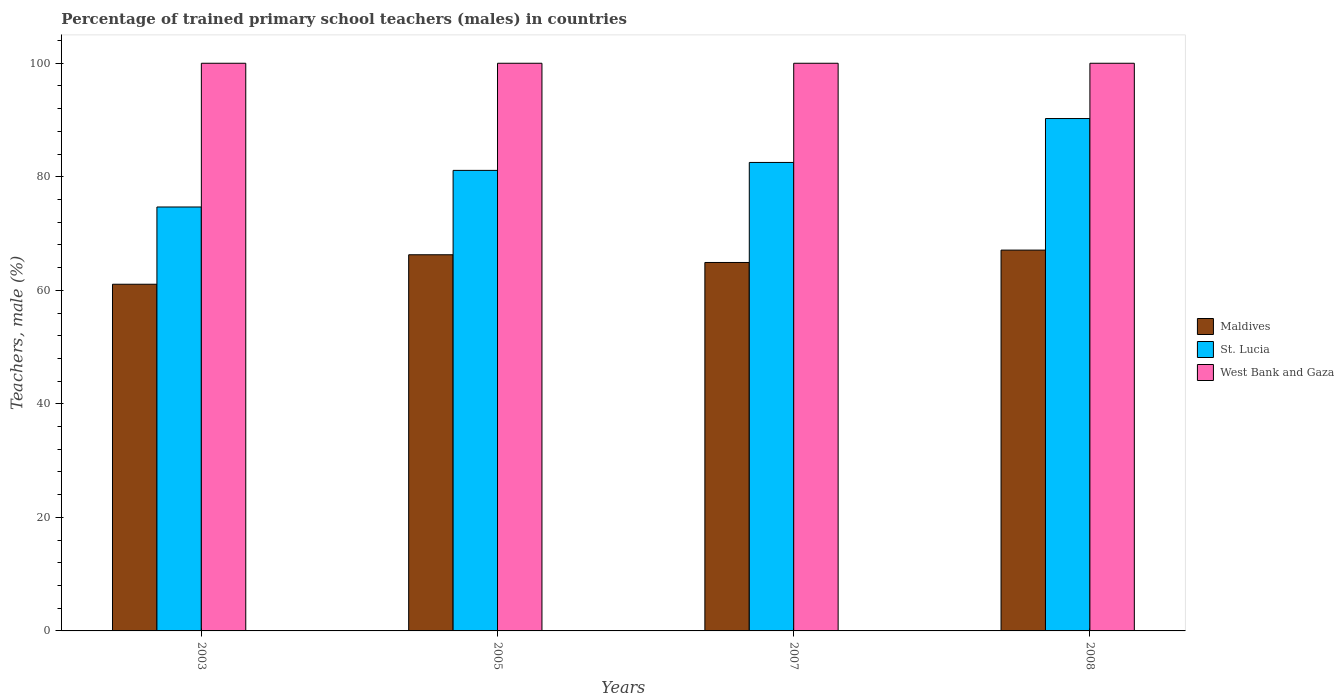How many different coloured bars are there?
Keep it short and to the point. 3. How many groups of bars are there?
Provide a short and direct response. 4. Are the number of bars per tick equal to the number of legend labels?
Give a very brief answer. Yes. Are the number of bars on each tick of the X-axis equal?
Provide a succinct answer. Yes. How many bars are there on the 1st tick from the right?
Offer a terse response. 3. In how many cases, is the number of bars for a given year not equal to the number of legend labels?
Provide a short and direct response. 0. What is the percentage of trained primary school teachers (males) in St. Lucia in 2008?
Offer a terse response. 90.26. Across all years, what is the maximum percentage of trained primary school teachers (males) in West Bank and Gaza?
Your response must be concise. 100. Across all years, what is the minimum percentage of trained primary school teachers (males) in Maldives?
Ensure brevity in your answer.  61.07. In which year was the percentage of trained primary school teachers (males) in St. Lucia maximum?
Offer a terse response. 2008. What is the total percentage of trained primary school teachers (males) in St. Lucia in the graph?
Provide a succinct answer. 328.6. What is the difference between the percentage of trained primary school teachers (males) in St. Lucia in 2005 and that in 2007?
Offer a terse response. -1.4. What is the difference between the percentage of trained primary school teachers (males) in West Bank and Gaza in 2007 and the percentage of trained primary school teachers (males) in Maldives in 2003?
Your answer should be very brief. 38.93. What is the average percentage of trained primary school teachers (males) in Maldives per year?
Provide a succinct answer. 64.83. In the year 2007, what is the difference between the percentage of trained primary school teachers (males) in Maldives and percentage of trained primary school teachers (males) in West Bank and Gaza?
Offer a very short reply. -35.09. In how many years, is the percentage of trained primary school teachers (males) in St. Lucia greater than 12 %?
Offer a very short reply. 4. What is the ratio of the percentage of trained primary school teachers (males) in St. Lucia in 2003 to that in 2007?
Ensure brevity in your answer.  0.9. Is the difference between the percentage of trained primary school teachers (males) in Maldives in 2005 and 2007 greater than the difference between the percentage of trained primary school teachers (males) in West Bank and Gaza in 2005 and 2007?
Ensure brevity in your answer.  Yes. What is the difference between the highest and the second highest percentage of trained primary school teachers (males) in St. Lucia?
Your response must be concise. 7.73. What is the difference between the highest and the lowest percentage of trained primary school teachers (males) in St. Lucia?
Ensure brevity in your answer.  15.58. Is the sum of the percentage of trained primary school teachers (males) in Maldives in 2005 and 2008 greater than the maximum percentage of trained primary school teachers (males) in West Bank and Gaza across all years?
Ensure brevity in your answer.  Yes. What does the 2nd bar from the left in 2007 represents?
Your response must be concise. St. Lucia. What does the 3rd bar from the right in 2007 represents?
Your answer should be very brief. Maldives. Is it the case that in every year, the sum of the percentage of trained primary school teachers (males) in West Bank and Gaza and percentage of trained primary school teachers (males) in St. Lucia is greater than the percentage of trained primary school teachers (males) in Maldives?
Your answer should be compact. Yes. How many bars are there?
Provide a short and direct response. 12. Are all the bars in the graph horizontal?
Offer a very short reply. No. What is the difference between two consecutive major ticks on the Y-axis?
Offer a very short reply. 20. Are the values on the major ticks of Y-axis written in scientific E-notation?
Your answer should be compact. No. How many legend labels are there?
Make the answer very short. 3. What is the title of the graph?
Provide a succinct answer. Percentage of trained primary school teachers (males) in countries. What is the label or title of the X-axis?
Your answer should be very brief. Years. What is the label or title of the Y-axis?
Your answer should be compact. Teachers, male (%). What is the Teachers, male (%) of Maldives in 2003?
Your answer should be very brief. 61.07. What is the Teachers, male (%) in St. Lucia in 2003?
Give a very brief answer. 74.68. What is the Teachers, male (%) in Maldives in 2005?
Your response must be concise. 66.27. What is the Teachers, male (%) of St. Lucia in 2005?
Your answer should be very brief. 81.13. What is the Teachers, male (%) of Maldives in 2007?
Offer a terse response. 64.91. What is the Teachers, male (%) in St. Lucia in 2007?
Your answer should be compact. 82.53. What is the Teachers, male (%) of Maldives in 2008?
Provide a short and direct response. 67.08. What is the Teachers, male (%) of St. Lucia in 2008?
Give a very brief answer. 90.26. Across all years, what is the maximum Teachers, male (%) in Maldives?
Give a very brief answer. 67.08. Across all years, what is the maximum Teachers, male (%) in St. Lucia?
Provide a succinct answer. 90.26. Across all years, what is the maximum Teachers, male (%) of West Bank and Gaza?
Your response must be concise. 100. Across all years, what is the minimum Teachers, male (%) in Maldives?
Your response must be concise. 61.07. Across all years, what is the minimum Teachers, male (%) in St. Lucia?
Ensure brevity in your answer.  74.68. What is the total Teachers, male (%) of Maldives in the graph?
Your answer should be compact. 259.33. What is the total Teachers, male (%) in St. Lucia in the graph?
Make the answer very short. 328.6. What is the difference between the Teachers, male (%) of Maldives in 2003 and that in 2005?
Offer a very short reply. -5.19. What is the difference between the Teachers, male (%) of St. Lucia in 2003 and that in 2005?
Offer a terse response. -6.45. What is the difference between the Teachers, male (%) of West Bank and Gaza in 2003 and that in 2005?
Provide a succinct answer. 0. What is the difference between the Teachers, male (%) in Maldives in 2003 and that in 2007?
Provide a short and direct response. -3.84. What is the difference between the Teachers, male (%) in St. Lucia in 2003 and that in 2007?
Offer a very short reply. -7.85. What is the difference between the Teachers, male (%) of Maldives in 2003 and that in 2008?
Your answer should be compact. -6.01. What is the difference between the Teachers, male (%) in St. Lucia in 2003 and that in 2008?
Give a very brief answer. -15.58. What is the difference between the Teachers, male (%) of Maldives in 2005 and that in 2007?
Provide a succinct answer. 1.36. What is the difference between the Teachers, male (%) in St. Lucia in 2005 and that in 2007?
Give a very brief answer. -1.4. What is the difference between the Teachers, male (%) of Maldives in 2005 and that in 2008?
Keep it short and to the point. -0.82. What is the difference between the Teachers, male (%) in St. Lucia in 2005 and that in 2008?
Give a very brief answer. -9.13. What is the difference between the Teachers, male (%) in Maldives in 2007 and that in 2008?
Ensure brevity in your answer.  -2.18. What is the difference between the Teachers, male (%) of St. Lucia in 2007 and that in 2008?
Your answer should be compact. -7.73. What is the difference between the Teachers, male (%) of West Bank and Gaza in 2007 and that in 2008?
Ensure brevity in your answer.  0. What is the difference between the Teachers, male (%) of Maldives in 2003 and the Teachers, male (%) of St. Lucia in 2005?
Ensure brevity in your answer.  -20.06. What is the difference between the Teachers, male (%) of Maldives in 2003 and the Teachers, male (%) of West Bank and Gaza in 2005?
Your answer should be very brief. -38.93. What is the difference between the Teachers, male (%) of St. Lucia in 2003 and the Teachers, male (%) of West Bank and Gaza in 2005?
Provide a succinct answer. -25.32. What is the difference between the Teachers, male (%) in Maldives in 2003 and the Teachers, male (%) in St. Lucia in 2007?
Your answer should be compact. -21.46. What is the difference between the Teachers, male (%) of Maldives in 2003 and the Teachers, male (%) of West Bank and Gaza in 2007?
Offer a very short reply. -38.93. What is the difference between the Teachers, male (%) in St. Lucia in 2003 and the Teachers, male (%) in West Bank and Gaza in 2007?
Provide a short and direct response. -25.32. What is the difference between the Teachers, male (%) in Maldives in 2003 and the Teachers, male (%) in St. Lucia in 2008?
Your answer should be very brief. -29.19. What is the difference between the Teachers, male (%) in Maldives in 2003 and the Teachers, male (%) in West Bank and Gaza in 2008?
Provide a succinct answer. -38.93. What is the difference between the Teachers, male (%) of St. Lucia in 2003 and the Teachers, male (%) of West Bank and Gaza in 2008?
Your response must be concise. -25.32. What is the difference between the Teachers, male (%) in Maldives in 2005 and the Teachers, male (%) in St. Lucia in 2007?
Your answer should be compact. -16.26. What is the difference between the Teachers, male (%) in Maldives in 2005 and the Teachers, male (%) in West Bank and Gaza in 2007?
Your answer should be compact. -33.73. What is the difference between the Teachers, male (%) of St. Lucia in 2005 and the Teachers, male (%) of West Bank and Gaza in 2007?
Offer a very short reply. -18.87. What is the difference between the Teachers, male (%) in Maldives in 2005 and the Teachers, male (%) in St. Lucia in 2008?
Provide a succinct answer. -24. What is the difference between the Teachers, male (%) of Maldives in 2005 and the Teachers, male (%) of West Bank and Gaza in 2008?
Keep it short and to the point. -33.73. What is the difference between the Teachers, male (%) of St. Lucia in 2005 and the Teachers, male (%) of West Bank and Gaza in 2008?
Ensure brevity in your answer.  -18.87. What is the difference between the Teachers, male (%) of Maldives in 2007 and the Teachers, male (%) of St. Lucia in 2008?
Your response must be concise. -25.35. What is the difference between the Teachers, male (%) of Maldives in 2007 and the Teachers, male (%) of West Bank and Gaza in 2008?
Ensure brevity in your answer.  -35.09. What is the difference between the Teachers, male (%) of St. Lucia in 2007 and the Teachers, male (%) of West Bank and Gaza in 2008?
Offer a terse response. -17.47. What is the average Teachers, male (%) of Maldives per year?
Make the answer very short. 64.83. What is the average Teachers, male (%) in St. Lucia per year?
Your response must be concise. 82.15. What is the average Teachers, male (%) of West Bank and Gaza per year?
Provide a succinct answer. 100. In the year 2003, what is the difference between the Teachers, male (%) of Maldives and Teachers, male (%) of St. Lucia?
Offer a very short reply. -13.61. In the year 2003, what is the difference between the Teachers, male (%) in Maldives and Teachers, male (%) in West Bank and Gaza?
Offer a terse response. -38.93. In the year 2003, what is the difference between the Teachers, male (%) of St. Lucia and Teachers, male (%) of West Bank and Gaza?
Provide a short and direct response. -25.32. In the year 2005, what is the difference between the Teachers, male (%) in Maldives and Teachers, male (%) in St. Lucia?
Your answer should be compact. -14.86. In the year 2005, what is the difference between the Teachers, male (%) of Maldives and Teachers, male (%) of West Bank and Gaza?
Ensure brevity in your answer.  -33.73. In the year 2005, what is the difference between the Teachers, male (%) of St. Lucia and Teachers, male (%) of West Bank and Gaza?
Offer a very short reply. -18.87. In the year 2007, what is the difference between the Teachers, male (%) of Maldives and Teachers, male (%) of St. Lucia?
Give a very brief answer. -17.62. In the year 2007, what is the difference between the Teachers, male (%) in Maldives and Teachers, male (%) in West Bank and Gaza?
Your answer should be compact. -35.09. In the year 2007, what is the difference between the Teachers, male (%) of St. Lucia and Teachers, male (%) of West Bank and Gaza?
Offer a terse response. -17.47. In the year 2008, what is the difference between the Teachers, male (%) in Maldives and Teachers, male (%) in St. Lucia?
Provide a short and direct response. -23.18. In the year 2008, what is the difference between the Teachers, male (%) of Maldives and Teachers, male (%) of West Bank and Gaza?
Your answer should be very brief. -32.92. In the year 2008, what is the difference between the Teachers, male (%) of St. Lucia and Teachers, male (%) of West Bank and Gaza?
Offer a terse response. -9.74. What is the ratio of the Teachers, male (%) in Maldives in 2003 to that in 2005?
Keep it short and to the point. 0.92. What is the ratio of the Teachers, male (%) in St. Lucia in 2003 to that in 2005?
Offer a very short reply. 0.92. What is the ratio of the Teachers, male (%) of West Bank and Gaza in 2003 to that in 2005?
Offer a very short reply. 1. What is the ratio of the Teachers, male (%) in Maldives in 2003 to that in 2007?
Provide a short and direct response. 0.94. What is the ratio of the Teachers, male (%) of St. Lucia in 2003 to that in 2007?
Provide a short and direct response. 0.9. What is the ratio of the Teachers, male (%) of West Bank and Gaza in 2003 to that in 2007?
Your answer should be very brief. 1. What is the ratio of the Teachers, male (%) of Maldives in 2003 to that in 2008?
Offer a very short reply. 0.91. What is the ratio of the Teachers, male (%) in St. Lucia in 2003 to that in 2008?
Make the answer very short. 0.83. What is the ratio of the Teachers, male (%) in West Bank and Gaza in 2003 to that in 2008?
Your answer should be compact. 1. What is the ratio of the Teachers, male (%) in Maldives in 2005 to that in 2007?
Your response must be concise. 1.02. What is the ratio of the Teachers, male (%) in St. Lucia in 2005 to that in 2007?
Provide a succinct answer. 0.98. What is the ratio of the Teachers, male (%) of St. Lucia in 2005 to that in 2008?
Offer a terse response. 0.9. What is the ratio of the Teachers, male (%) of Maldives in 2007 to that in 2008?
Give a very brief answer. 0.97. What is the ratio of the Teachers, male (%) of St. Lucia in 2007 to that in 2008?
Provide a short and direct response. 0.91. What is the difference between the highest and the second highest Teachers, male (%) of Maldives?
Offer a terse response. 0.82. What is the difference between the highest and the second highest Teachers, male (%) in St. Lucia?
Offer a very short reply. 7.73. What is the difference between the highest and the second highest Teachers, male (%) of West Bank and Gaza?
Your response must be concise. 0. What is the difference between the highest and the lowest Teachers, male (%) in Maldives?
Offer a terse response. 6.01. What is the difference between the highest and the lowest Teachers, male (%) in St. Lucia?
Make the answer very short. 15.58. What is the difference between the highest and the lowest Teachers, male (%) of West Bank and Gaza?
Offer a terse response. 0. 